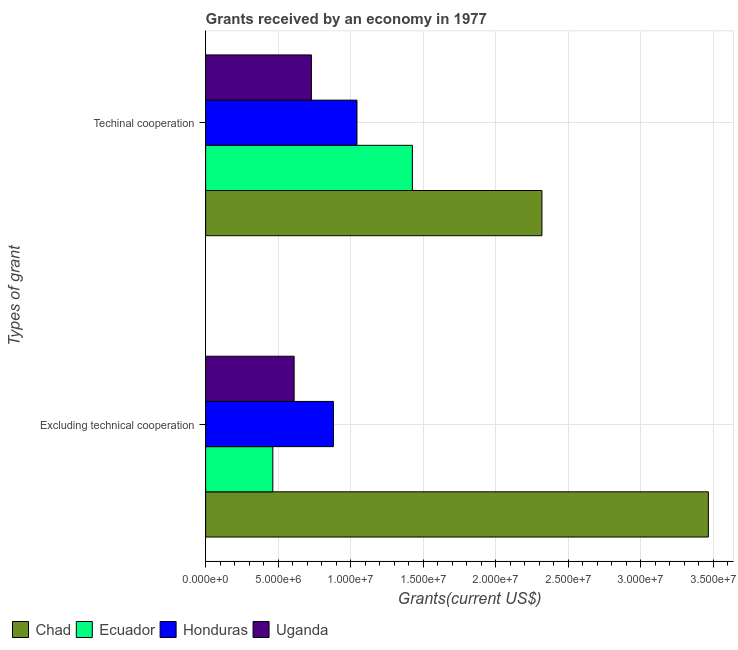How many different coloured bars are there?
Keep it short and to the point. 4. Are the number of bars per tick equal to the number of legend labels?
Your response must be concise. Yes. Are the number of bars on each tick of the Y-axis equal?
Give a very brief answer. Yes. What is the label of the 2nd group of bars from the top?
Offer a terse response. Excluding technical cooperation. What is the amount of grants received(excluding technical cooperation) in Uganda?
Your response must be concise. 6.10e+06. Across all countries, what is the maximum amount of grants received(including technical cooperation)?
Offer a terse response. 2.32e+07. Across all countries, what is the minimum amount of grants received(excluding technical cooperation)?
Make the answer very short. 4.63e+06. In which country was the amount of grants received(including technical cooperation) maximum?
Give a very brief answer. Chad. In which country was the amount of grants received(including technical cooperation) minimum?
Provide a succinct answer. Uganda. What is the total amount of grants received(including technical cooperation) in the graph?
Provide a succinct answer. 5.52e+07. What is the difference between the amount of grants received(including technical cooperation) in Honduras and that in Ecuador?
Keep it short and to the point. -3.82e+06. What is the difference between the amount of grants received(including technical cooperation) in Chad and the amount of grants received(excluding technical cooperation) in Honduras?
Offer a terse response. 1.44e+07. What is the average amount of grants received(excluding technical cooperation) per country?
Provide a succinct answer. 1.35e+07. What is the difference between the amount of grants received(excluding technical cooperation) and amount of grants received(including technical cooperation) in Honduras?
Your answer should be compact. -1.62e+06. What is the ratio of the amount of grants received(including technical cooperation) in Uganda to that in Chad?
Make the answer very short. 0.31. Is the amount of grants received(including technical cooperation) in Uganda less than that in Ecuador?
Your response must be concise. Yes. What does the 3rd bar from the top in Techinal cooperation represents?
Give a very brief answer. Ecuador. What does the 1st bar from the bottom in Techinal cooperation represents?
Provide a succinct answer. Chad. How many bars are there?
Offer a terse response. 8. Are the values on the major ticks of X-axis written in scientific E-notation?
Provide a short and direct response. Yes. How are the legend labels stacked?
Your response must be concise. Horizontal. What is the title of the graph?
Give a very brief answer. Grants received by an economy in 1977. Does "Macao" appear as one of the legend labels in the graph?
Provide a succinct answer. No. What is the label or title of the X-axis?
Your answer should be very brief. Grants(current US$). What is the label or title of the Y-axis?
Ensure brevity in your answer.  Types of grant. What is the Grants(current US$) of Chad in Excluding technical cooperation?
Give a very brief answer. 3.46e+07. What is the Grants(current US$) in Ecuador in Excluding technical cooperation?
Provide a short and direct response. 4.63e+06. What is the Grants(current US$) of Honduras in Excluding technical cooperation?
Give a very brief answer. 8.81e+06. What is the Grants(current US$) of Uganda in Excluding technical cooperation?
Offer a very short reply. 6.10e+06. What is the Grants(current US$) of Chad in Techinal cooperation?
Your answer should be compact. 2.32e+07. What is the Grants(current US$) of Ecuador in Techinal cooperation?
Provide a short and direct response. 1.42e+07. What is the Grants(current US$) of Honduras in Techinal cooperation?
Offer a very short reply. 1.04e+07. What is the Grants(current US$) of Uganda in Techinal cooperation?
Offer a very short reply. 7.29e+06. Across all Types of grant, what is the maximum Grants(current US$) in Chad?
Provide a succinct answer. 3.46e+07. Across all Types of grant, what is the maximum Grants(current US$) in Ecuador?
Offer a terse response. 1.42e+07. Across all Types of grant, what is the maximum Grants(current US$) of Honduras?
Keep it short and to the point. 1.04e+07. Across all Types of grant, what is the maximum Grants(current US$) of Uganda?
Your response must be concise. 7.29e+06. Across all Types of grant, what is the minimum Grants(current US$) of Chad?
Your answer should be very brief. 2.32e+07. Across all Types of grant, what is the minimum Grants(current US$) of Ecuador?
Your answer should be compact. 4.63e+06. Across all Types of grant, what is the minimum Grants(current US$) of Honduras?
Your response must be concise. 8.81e+06. Across all Types of grant, what is the minimum Grants(current US$) in Uganda?
Your response must be concise. 6.10e+06. What is the total Grants(current US$) of Chad in the graph?
Your answer should be compact. 5.78e+07. What is the total Grants(current US$) in Ecuador in the graph?
Keep it short and to the point. 1.89e+07. What is the total Grants(current US$) in Honduras in the graph?
Your response must be concise. 1.92e+07. What is the total Grants(current US$) in Uganda in the graph?
Your response must be concise. 1.34e+07. What is the difference between the Grants(current US$) of Chad in Excluding technical cooperation and that in Techinal cooperation?
Make the answer very short. 1.15e+07. What is the difference between the Grants(current US$) of Ecuador in Excluding technical cooperation and that in Techinal cooperation?
Keep it short and to the point. -9.62e+06. What is the difference between the Grants(current US$) of Honduras in Excluding technical cooperation and that in Techinal cooperation?
Ensure brevity in your answer.  -1.62e+06. What is the difference between the Grants(current US$) of Uganda in Excluding technical cooperation and that in Techinal cooperation?
Provide a short and direct response. -1.19e+06. What is the difference between the Grants(current US$) in Chad in Excluding technical cooperation and the Grants(current US$) in Ecuador in Techinal cooperation?
Offer a very short reply. 2.04e+07. What is the difference between the Grants(current US$) of Chad in Excluding technical cooperation and the Grants(current US$) of Honduras in Techinal cooperation?
Your answer should be very brief. 2.42e+07. What is the difference between the Grants(current US$) of Chad in Excluding technical cooperation and the Grants(current US$) of Uganda in Techinal cooperation?
Ensure brevity in your answer.  2.74e+07. What is the difference between the Grants(current US$) of Ecuador in Excluding technical cooperation and the Grants(current US$) of Honduras in Techinal cooperation?
Your answer should be compact. -5.80e+06. What is the difference between the Grants(current US$) in Ecuador in Excluding technical cooperation and the Grants(current US$) in Uganda in Techinal cooperation?
Your answer should be compact. -2.66e+06. What is the difference between the Grants(current US$) in Honduras in Excluding technical cooperation and the Grants(current US$) in Uganda in Techinal cooperation?
Keep it short and to the point. 1.52e+06. What is the average Grants(current US$) in Chad per Types of grant?
Your answer should be compact. 2.89e+07. What is the average Grants(current US$) of Ecuador per Types of grant?
Your response must be concise. 9.44e+06. What is the average Grants(current US$) in Honduras per Types of grant?
Offer a very short reply. 9.62e+06. What is the average Grants(current US$) in Uganda per Types of grant?
Provide a succinct answer. 6.70e+06. What is the difference between the Grants(current US$) in Chad and Grants(current US$) in Ecuador in Excluding technical cooperation?
Offer a terse response. 3.00e+07. What is the difference between the Grants(current US$) of Chad and Grants(current US$) of Honduras in Excluding technical cooperation?
Provide a succinct answer. 2.58e+07. What is the difference between the Grants(current US$) of Chad and Grants(current US$) of Uganda in Excluding technical cooperation?
Ensure brevity in your answer.  2.86e+07. What is the difference between the Grants(current US$) in Ecuador and Grants(current US$) in Honduras in Excluding technical cooperation?
Offer a terse response. -4.18e+06. What is the difference between the Grants(current US$) in Ecuador and Grants(current US$) in Uganda in Excluding technical cooperation?
Offer a terse response. -1.47e+06. What is the difference between the Grants(current US$) in Honduras and Grants(current US$) in Uganda in Excluding technical cooperation?
Your response must be concise. 2.71e+06. What is the difference between the Grants(current US$) of Chad and Grants(current US$) of Ecuador in Techinal cooperation?
Ensure brevity in your answer.  8.93e+06. What is the difference between the Grants(current US$) of Chad and Grants(current US$) of Honduras in Techinal cooperation?
Provide a short and direct response. 1.28e+07. What is the difference between the Grants(current US$) in Chad and Grants(current US$) in Uganda in Techinal cooperation?
Provide a succinct answer. 1.59e+07. What is the difference between the Grants(current US$) of Ecuador and Grants(current US$) of Honduras in Techinal cooperation?
Offer a terse response. 3.82e+06. What is the difference between the Grants(current US$) of Ecuador and Grants(current US$) of Uganda in Techinal cooperation?
Your answer should be compact. 6.96e+06. What is the difference between the Grants(current US$) in Honduras and Grants(current US$) in Uganda in Techinal cooperation?
Your response must be concise. 3.14e+06. What is the ratio of the Grants(current US$) in Chad in Excluding technical cooperation to that in Techinal cooperation?
Your answer should be very brief. 1.49. What is the ratio of the Grants(current US$) in Ecuador in Excluding technical cooperation to that in Techinal cooperation?
Keep it short and to the point. 0.32. What is the ratio of the Grants(current US$) in Honduras in Excluding technical cooperation to that in Techinal cooperation?
Give a very brief answer. 0.84. What is the ratio of the Grants(current US$) in Uganda in Excluding technical cooperation to that in Techinal cooperation?
Offer a very short reply. 0.84. What is the difference between the highest and the second highest Grants(current US$) in Chad?
Keep it short and to the point. 1.15e+07. What is the difference between the highest and the second highest Grants(current US$) in Ecuador?
Your response must be concise. 9.62e+06. What is the difference between the highest and the second highest Grants(current US$) in Honduras?
Offer a very short reply. 1.62e+06. What is the difference between the highest and the second highest Grants(current US$) in Uganda?
Your answer should be very brief. 1.19e+06. What is the difference between the highest and the lowest Grants(current US$) of Chad?
Provide a succinct answer. 1.15e+07. What is the difference between the highest and the lowest Grants(current US$) in Ecuador?
Your answer should be very brief. 9.62e+06. What is the difference between the highest and the lowest Grants(current US$) in Honduras?
Ensure brevity in your answer.  1.62e+06. What is the difference between the highest and the lowest Grants(current US$) in Uganda?
Make the answer very short. 1.19e+06. 